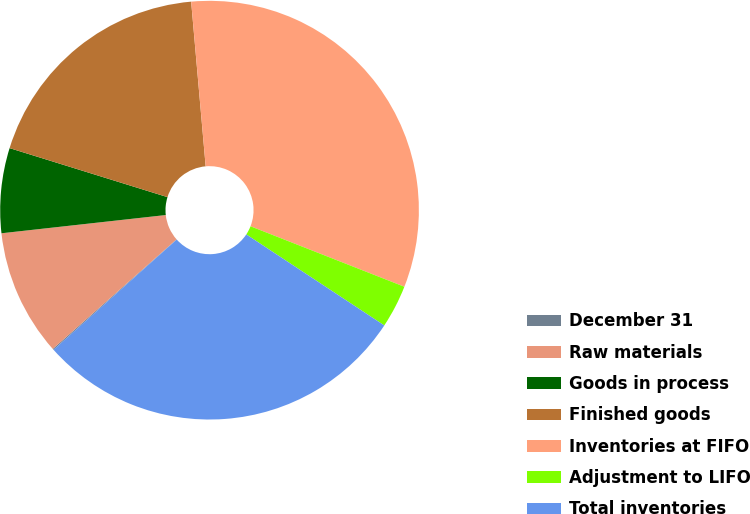<chart> <loc_0><loc_0><loc_500><loc_500><pie_chart><fcel>December 31<fcel>Raw materials<fcel>Goods in process<fcel>Finished goods<fcel>Inventories at FIFO<fcel>Adjustment to LIFO<fcel>Total inventories<nl><fcel>0.09%<fcel>9.77%<fcel>6.55%<fcel>18.81%<fcel>32.36%<fcel>3.32%<fcel>29.1%<nl></chart> 